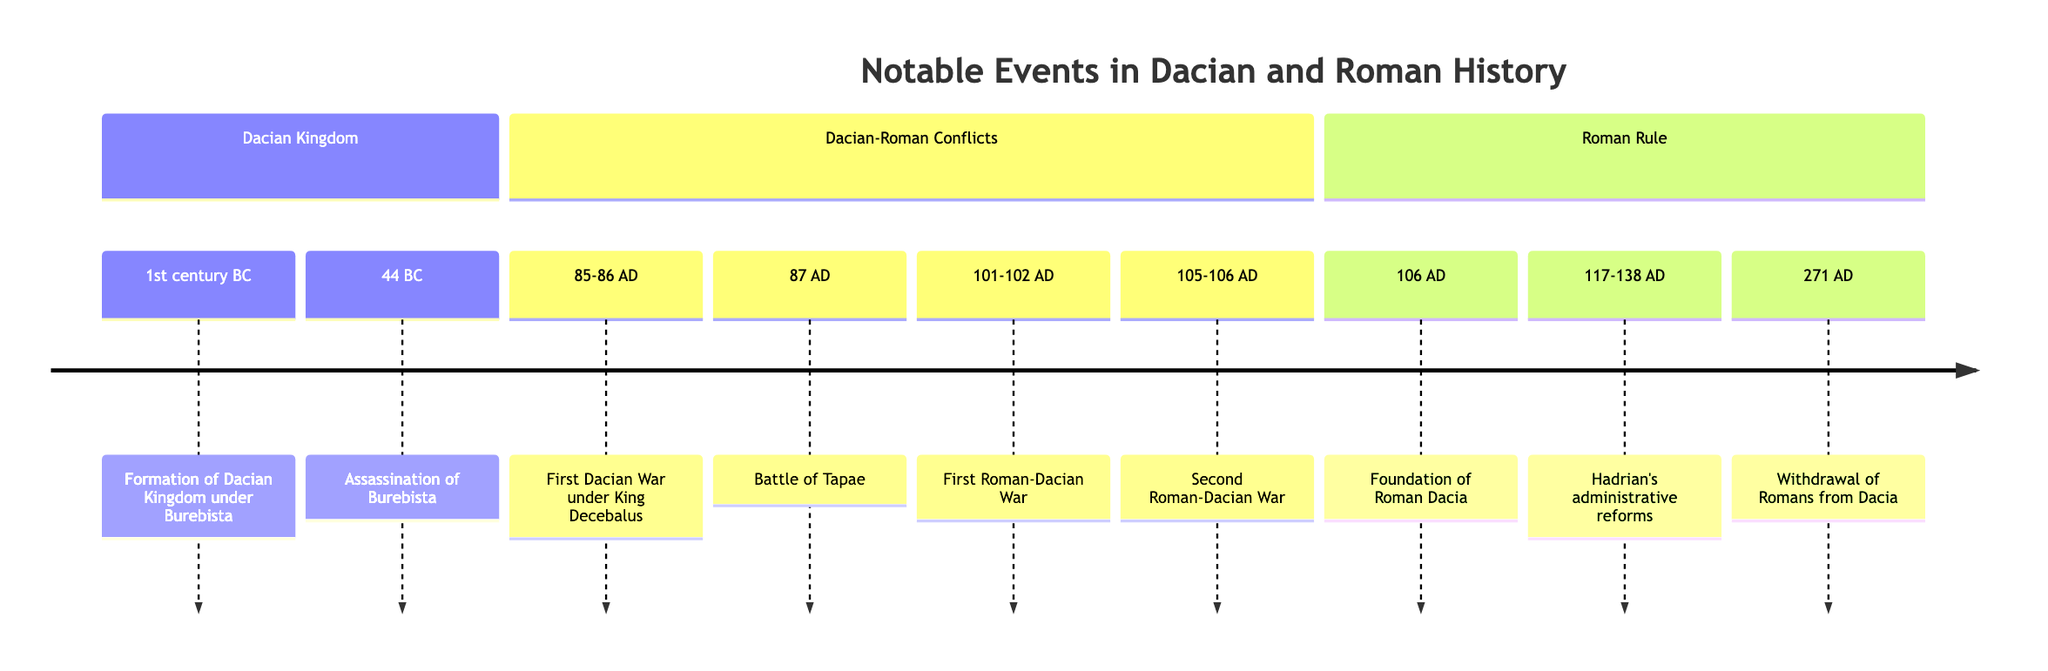What year marks the foundation of Roman Dacia? The timeline indicates the event "Foundation of Roman Dacia" occurs in the year 106 AD.
Answer: 106 AD Who was the ruler of the Dacian Kingdom during its formation? The timeline specifies that Burebista is the ruler who formed the Dacian Kingdom in the 1st century BC.
Answer: Burebista What significant event occurred in 44 BC? According to the timeline, the "Assassination of Burebista" is the notable event that took place in 44 BC.
Answer: Assassination of Burebista How many Roman-Dacian wars are listed in the timeline? The timeline shows two distinct wars are mentioned: the First Roman-Dacian War and the Second Roman-Dacian War, totaling two wars.
Answer: 2 In which years did Emperor Trajan launch his military campaigns against Dacia? The timeline outlines that the First Roman-Dacian War occurred between 101-102 AD and the Second Roman-Dacian War from 105-106 AD under Emperor Trajan’s command.
Answer: 101-106 AD What happened at the Battle of Tapae? The timeline states that the Dacian forces achieved a significant victory against the Romans at the Battle of Tapae in 87 AD.
Answer: Significant victory What period did Hadrian’s administrative reforms take place in Roman Dacia? The timeline notes that Hadrian’s administrative reforms occurred between 117-138 AD, indicating a specific range of years for these reforms.
Answer: 117-138 AD What was the outcome of the Second Roman-Dacian War? The timeline mentions that the Second Roman-Dacian War resulted in the defeat of King Decebalus and the annexation of Dacia as a Roman province.
Answer: Defeat of King Decebalus What does the timeline reveal about the end of Roman rule in Dacia? The timeline indicates that in 271 AD, Emperor Aurelian ordered a withdrawal of Roman legions and administration, effectively ending Roman rule in Dacia.
Answer: Withdrawal of Romans 